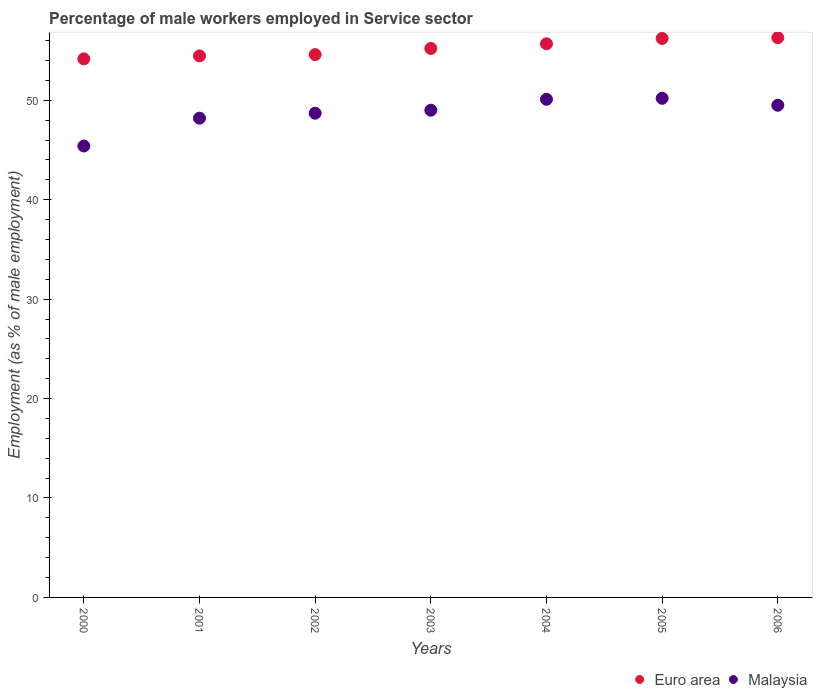What is the percentage of male workers employed in Service sector in Malaysia in 2004?
Your answer should be compact. 50.1. Across all years, what is the maximum percentage of male workers employed in Service sector in Malaysia?
Your answer should be compact. 50.2. Across all years, what is the minimum percentage of male workers employed in Service sector in Euro area?
Your answer should be very brief. 54.17. In which year was the percentage of male workers employed in Service sector in Malaysia maximum?
Provide a short and direct response. 2005. What is the total percentage of male workers employed in Service sector in Euro area in the graph?
Your answer should be very brief. 386.64. What is the difference between the percentage of male workers employed in Service sector in Euro area in 2005 and the percentage of male workers employed in Service sector in Malaysia in 2000?
Offer a terse response. 10.82. What is the average percentage of male workers employed in Service sector in Euro area per year?
Offer a terse response. 55.23. In the year 2004, what is the difference between the percentage of male workers employed in Service sector in Euro area and percentage of male workers employed in Service sector in Malaysia?
Give a very brief answer. 5.58. What is the ratio of the percentage of male workers employed in Service sector in Malaysia in 2001 to that in 2004?
Offer a terse response. 0.96. What is the difference between the highest and the second highest percentage of male workers employed in Service sector in Malaysia?
Offer a terse response. 0.1. What is the difference between the highest and the lowest percentage of male workers employed in Service sector in Euro area?
Offer a very short reply. 2.13. Is the sum of the percentage of male workers employed in Service sector in Euro area in 2003 and 2005 greater than the maximum percentage of male workers employed in Service sector in Malaysia across all years?
Your answer should be compact. Yes. Does the percentage of male workers employed in Service sector in Euro area monotonically increase over the years?
Ensure brevity in your answer.  Yes. Is the percentage of male workers employed in Service sector in Euro area strictly less than the percentage of male workers employed in Service sector in Malaysia over the years?
Offer a terse response. No. How many dotlines are there?
Offer a terse response. 2. How many years are there in the graph?
Offer a very short reply. 7. What is the difference between two consecutive major ticks on the Y-axis?
Keep it short and to the point. 10. Does the graph contain grids?
Provide a succinct answer. No. Where does the legend appear in the graph?
Give a very brief answer. Bottom right. What is the title of the graph?
Your answer should be compact. Percentage of male workers employed in Service sector. Does "Kosovo" appear as one of the legend labels in the graph?
Provide a short and direct response. No. What is the label or title of the Y-axis?
Offer a very short reply. Employment (as % of male employment). What is the Employment (as % of male employment) of Euro area in 2000?
Keep it short and to the point. 54.17. What is the Employment (as % of male employment) of Malaysia in 2000?
Your answer should be compact. 45.4. What is the Employment (as % of male employment) of Euro area in 2001?
Your answer should be compact. 54.46. What is the Employment (as % of male employment) of Malaysia in 2001?
Give a very brief answer. 48.2. What is the Employment (as % of male employment) in Euro area in 2002?
Your response must be concise. 54.6. What is the Employment (as % of male employment) in Malaysia in 2002?
Provide a succinct answer. 48.7. What is the Employment (as % of male employment) in Euro area in 2003?
Give a very brief answer. 55.21. What is the Employment (as % of male employment) of Malaysia in 2003?
Make the answer very short. 49. What is the Employment (as % of male employment) of Euro area in 2004?
Ensure brevity in your answer.  55.68. What is the Employment (as % of male employment) in Malaysia in 2004?
Provide a succinct answer. 50.1. What is the Employment (as % of male employment) in Euro area in 2005?
Keep it short and to the point. 56.22. What is the Employment (as % of male employment) of Malaysia in 2005?
Offer a very short reply. 50.2. What is the Employment (as % of male employment) of Euro area in 2006?
Provide a succinct answer. 56.3. What is the Employment (as % of male employment) of Malaysia in 2006?
Offer a terse response. 49.5. Across all years, what is the maximum Employment (as % of male employment) of Euro area?
Keep it short and to the point. 56.3. Across all years, what is the maximum Employment (as % of male employment) in Malaysia?
Your answer should be compact. 50.2. Across all years, what is the minimum Employment (as % of male employment) of Euro area?
Give a very brief answer. 54.17. Across all years, what is the minimum Employment (as % of male employment) in Malaysia?
Your answer should be compact. 45.4. What is the total Employment (as % of male employment) in Euro area in the graph?
Give a very brief answer. 386.64. What is the total Employment (as % of male employment) of Malaysia in the graph?
Make the answer very short. 341.1. What is the difference between the Employment (as % of male employment) in Euro area in 2000 and that in 2001?
Give a very brief answer. -0.3. What is the difference between the Employment (as % of male employment) of Malaysia in 2000 and that in 2001?
Offer a terse response. -2.8. What is the difference between the Employment (as % of male employment) in Euro area in 2000 and that in 2002?
Give a very brief answer. -0.43. What is the difference between the Employment (as % of male employment) in Euro area in 2000 and that in 2003?
Offer a terse response. -1.05. What is the difference between the Employment (as % of male employment) in Euro area in 2000 and that in 2004?
Give a very brief answer. -1.52. What is the difference between the Employment (as % of male employment) in Euro area in 2000 and that in 2005?
Your answer should be compact. -2.05. What is the difference between the Employment (as % of male employment) of Malaysia in 2000 and that in 2005?
Your answer should be very brief. -4.8. What is the difference between the Employment (as % of male employment) in Euro area in 2000 and that in 2006?
Your response must be concise. -2.13. What is the difference between the Employment (as % of male employment) of Malaysia in 2000 and that in 2006?
Make the answer very short. -4.1. What is the difference between the Employment (as % of male employment) in Euro area in 2001 and that in 2002?
Keep it short and to the point. -0.13. What is the difference between the Employment (as % of male employment) in Euro area in 2001 and that in 2003?
Offer a terse response. -0.75. What is the difference between the Employment (as % of male employment) in Euro area in 2001 and that in 2004?
Keep it short and to the point. -1.22. What is the difference between the Employment (as % of male employment) in Euro area in 2001 and that in 2005?
Give a very brief answer. -1.76. What is the difference between the Employment (as % of male employment) of Malaysia in 2001 and that in 2005?
Your answer should be compact. -2. What is the difference between the Employment (as % of male employment) of Euro area in 2001 and that in 2006?
Your answer should be very brief. -1.83. What is the difference between the Employment (as % of male employment) in Malaysia in 2001 and that in 2006?
Keep it short and to the point. -1.3. What is the difference between the Employment (as % of male employment) in Euro area in 2002 and that in 2003?
Make the answer very short. -0.62. What is the difference between the Employment (as % of male employment) of Euro area in 2002 and that in 2004?
Give a very brief answer. -1.09. What is the difference between the Employment (as % of male employment) of Euro area in 2002 and that in 2005?
Provide a short and direct response. -1.62. What is the difference between the Employment (as % of male employment) of Euro area in 2002 and that in 2006?
Your response must be concise. -1.7. What is the difference between the Employment (as % of male employment) of Malaysia in 2002 and that in 2006?
Provide a succinct answer. -0.8. What is the difference between the Employment (as % of male employment) of Euro area in 2003 and that in 2004?
Make the answer very short. -0.47. What is the difference between the Employment (as % of male employment) in Euro area in 2003 and that in 2005?
Keep it short and to the point. -1.01. What is the difference between the Employment (as % of male employment) of Malaysia in 2003 and that in 2005?
Offer a very short reply. -1.2. What is the difference between the Employment (as % of male employment) in Euro area in 2003 and that in 2006?
Ensure brevity in your answer.  -1.08. What is the difference between the Employment (as % of male employment) in Malaysia in 2003 and that in 2006?
Give a very brief answer. -0.5. What is the difference between the Employment (as % of male employment) in Euro area in 2004 and that in 2005?
Your answer should be very brief. -0.54. What is the difference between the Employment (as % of male employment) of Euro area in 2004 and that in 2006?
Your answer should be compact. -0.62. What is the difference between the Employment (as % of male employment) in Euro area in 2005 and that in 2006?
Provide a short and direct response. -0.08. What is the difference between the Employment (as % of male employment) of Malaysia in 2005 and that in 2006?
Offer a very short reply. 0.7. What is the difference between the Employment (as % of male employment) in Euro area in 2000 and the Employment (as % of male employment) in Malaysia in 2001?
Your response must be concise. 5.97. What is the difference between the Employment (as % of male employment) in Euro area in 2000 and the Employment (as % of male employment) in Malaysia in 2002?
Keep it short and to the point. 5.47. What is the difference between the Employment (as % of male employment) of Euro area in 2000 and the Employment (as % of male employment) of Malaysia in 2003?
Keep it short and to the point. 5.17. What is the difference between the Employment (as % of male employment) in Euro area in 2000 and the Employment (as % of male employment) in Malaysia in 2004?
Offer a terse response. 4.07. What is the difference between the Employment (as % of male employment) of Euro area in 2000 and the Employment (as % of male employment) of Malaysia in 2005?
Your response must be concise. 3.97. What is the difference between the Employment (as % of male employment) in Euro area in 2000 and the Employment (as % of male employment) in Malaysia in 2006?
Provide a short and direct response. 4.67. What is the difference between the Employment (as % of male employment) of Euro area in 2001 and the Employment (as % of male employment) of Malaysia in 2002?
Provide a succinct answer. 5.76. What is the difference between the Employment (as % of male employment) in Euro area in 2001 and the Employment (as % of male employment) in Malaysia in 2003?
Your answer should be very brief. 5.46. What is the difference between the Employment (as % of male employment) of Euro area in 2001 and the Employment (as % of male employment) of Malaysia in 2004?
Offer a terse response. 4.36. What is the difference between the Employment (as % of male employment) in Euro area in 2001 and the Employment (as % of male employment) in Malaysia in 2005?
Your answer should be compact. 4.26. What is the difference between the Employment (as % of male employment) in Euro area in 2001 and the Employment (as % of male employment) in Malaysia in 2006?
Ensure brevity in your answer.  4.96. What is the difference between the Employment (as % of male employment) of Euro area in 2002 and the Employment (as % of male employment) of Malaysia in 2003?
Your response must be concise. 5.6. What is the difference between the Employment (as % of male employment) of Euro area in 2002 and the Employment (as % of male employment) of Malaysia in 2004?
Your answer should be very brief. 4.5. What is the difference between the Employment (as % of male employment) of Euro area in 2002 and the Employment (as % of male employment) of Malaysia in 2005?
Your response must be concise. 4.4. What is the difference between the Employment (as % of male employment) in Euro area in 2002 and the Employment (as % of male employment) in Malaysia in 2006?
Provide a succinct answer. 5.1. What is the difference between the Employment (as % of male employment) of Euro area in 2003 and the Employment (as % of male employment) of Malaysia in 2004?
Your answer should be very brief. 5.11. What is the difference between the Employment (as % of male employment) in Euro area in 2003 and the Employment (as % of male employment) in Malaysia in 2005?
Offer a very short reply. 5.01. What is the difference between the Employment (as % of male employment) of Euro area in 2003 and the Employment (as % of male employment) of Malaysia in 2006?
Your answer should be compact. 5.71. What is the difference between the Employment (as % of male employment) in Euro area in 2004 and the Employment (as % of male employment) in Malaysia in 2005?
Your response must be concise. 5.48. What is the difference between the Employment (as % of male employment) in Euro area in 2004 and the Employment (as % of male employment) in Malaysia in 2006?
Your response must be concise. 6.18. What is the difference between the Employment (as % of male employment) in Euro area in 2005 and the Employment (as % of male employment) in Malaysia in 2006?
Your answer should be compact. 6.72. What is the average Employment (as % of male employment) of Euro area per year?
Make the answer very short. 55.23. What is the average Employment (as % of male employment) in Malaysia per year?
Offer a very short reply. 48.73. In the year 2000, what is the difference between the Employment (as % of male employment) in Euro area and Employment (as % of male employment) in Malaysia?
Offer a very short reply. 8.77. In the year 2001, what is the difference between the Employment (as % of male employment) in Euro area and Employment (as % of male employment) in Malaysia?
Give a very brief answer. 6.26. In the year 2002, what is the difference between the Employment (as % of male employment) in Euro area and Employment (as % of male employment) in Malaysia?
Keep it short and to the point. 5.9. In the year 2003, what is the difference between the Employment (as % of male employment) of Euro area and Employment (as % of male employment) of Malaysia?
Provide a succinct answer. 6.21. In the year 2004, what is the difference between the Employment (as % of male employment) in Euro area and Employment (as % of male employment) in Malaysia?
Offer a terse response. 5.58. In the year 2005, what is the difference between the Employment (as % of male employment) in Euro area and Employment (as % of male employment) in Malaysia?
Ensure brevity in your answer.  6.02. In the year 2006, what is the difference between the Employment (as % of male employment) in Euro area and Employment (as % of male employment) in Malaysia?
Keep it short and to the point. 6.8. What is the ratio of the Employment (as % of male employment) of Euro area in 2000 to that in 2001?
Keep it short and to the point. 0.99. What is the ratio of the Employment (as % of male employment) in Malaysia in 2000 to that in 2001?
Ensure brevity in your answer.  0.94. What is the ratio of the Employment (as % of male employment) in Euro area in 2000 to that in 2002?
Offer a terse response. 0.99. What is the ratio of the Employment (as % of male employment) in Malaysia in 2000 to that in 2002?
Offer a very short reply. 0.93. What is the ratio of the Employment (as % of male employment) in Malaysia in 2000 to that in 2003?
Make the answer very short. 0.93. What is the ratio of the Employment (as % of male employment) of Euro area in 2000 to that in 2004?
Make the answer very short. 0.97. What is the ratio of the Employment (as % of male employment) of Malaysia in 2000 to that in 2004?
Give a very brief answer. 0.91. What is the ratio of the Employment (as % of male employment) in Euro area in 2000 to that in 2005?
Offer a terse response. 0.96. What is the ratio of the Employment (as % of male employment) in Malaysia in 2000 to that in 2005?
Make the answer very short. 0.9. What is the ratio of the Employment (as % of male employment) of Euro area in 2000 to that in 2006?
Keep it short and to the point. 0.96. What is the ratio of the Employment (as % of male employment) of Malaysia in 2000 to that in 2006?
Your answer should be compact. 0.92. What is the ratio of the Employment (as % of male employment) of Euro area in 2001 to that in 2003?
Provide a succinct answer. 0.99. What is the ratio of the Employment (as % of male employment) in Malaysia in 2001 to that in 2003?
Your answer should be very brief. 0.98. What is the ratio of the Employment (as % of male employment) of Euro area in 2001 to that in 2004?
Your response must be concise. 0.98. What is the ratio of the Employment (as % of male employment) in Malaysia in 2001 to that in 2004?
Offer a very short reply. 0.96. What is the ratio of the Employment (as % of male employment) of Euro area in 2001 to that in 2005?
Give a very brief answer. 0.97. What is the ratio of the Employment (as % of male employment) in Malaysia in 2001 to that in 2005?
Keep it short and to the point. 0.96. What is the ratio of the Employment (as % of male employment) in Euro area in 2001 to that in 2006?
Keep it short and to the point. 0.97. What is the ratio of the Employment (as % of male employment) of Malaysia in 2001 to that in 2006?
Provide a short and direct response. 0.97. What is the ratio of the Employment (as % of male employment) of Euro area in 2002 to that in 2003?
Provide a succinct answer. 0.99. What is the ratio of the Employment (as % of male employment) of Malaysia in 2002 to that in 2003?
Provide a short and direct response. 0.99. What is the ratio of the Employment (as % of male employment) in Euro area in 2002 to that in 2004?
Offer a terse response. 0.98. What is the ratio of the Employment (as % of male employment) of Malaysia in 2002 to that in 2004?
Ensure brevity in your answer.  0.97. What is the ratio of the Employment (as % of male employment) in Euro area in 2002 to that in 2005?
Your answer should be very brief. 0.97. What is the ratio of the Employment (as % of male employment) in Malaysia in 2002 to that in 2005?
Make the answer very short. 0.97. What is the ratio of the Employment (as % of male employment) of Euro area in 2002 to that in 2006?
Make the answer very short. 0.97. What is the ratio of the Employment (as % of male employment) in Malaysia in 2002 to that in 2006?
Give a very brief answer. 0.98. What is the ratio of the Employment (as % of male employment) of Malaysia in 2003 to that in 2004?
Provide a short and direct response. 0.98. What is the ratio of the Employment (as % of male employment) of Euro area in 2003 to that in 2005?
Make the answer very short. 0.98. What is the ratio of the Employment (as % of male employment) of Malaysia in 2003 to that in 2005?
Keep it short and to the point. 0.98. What is the ratio of the Employment (as % of male employment) in Euro area in 2003 to that in 2006?
Keep it short and to the point. 0.98. What is the ratio of the Employment (as % of male employment) of Euro area in 2004 to that in 2005?
Ensure brevity in your answer.  0.99. What is the ratio of the Employment (as % of male employment) of Euro area in 2004 to that in 2006?
Ensure brevity in your answer.  0.99. What is the ratio of the Employment (as % of male employment) of Malaysia in 2004 to that in 2006?
Make the answer very short. 1.01. What is the ratio of the Employment (as % of male employment) in Malaysia in 2005 to that in 2006?
Keep it short and to the point. 1.01. What is the difference between the highest and the second highest Employment (as % of male employment) in Euro area?
Keep it short and to the point. 0.08. What is the difference between the highest and the lowest Employment (as % of male employment) in Euro area?
Provide a succinct answer. 2.13. What is the difference between the highest and the lowest Employment (as % of male employment) of Malaysia?
Offer a very short reply. 4.8. 